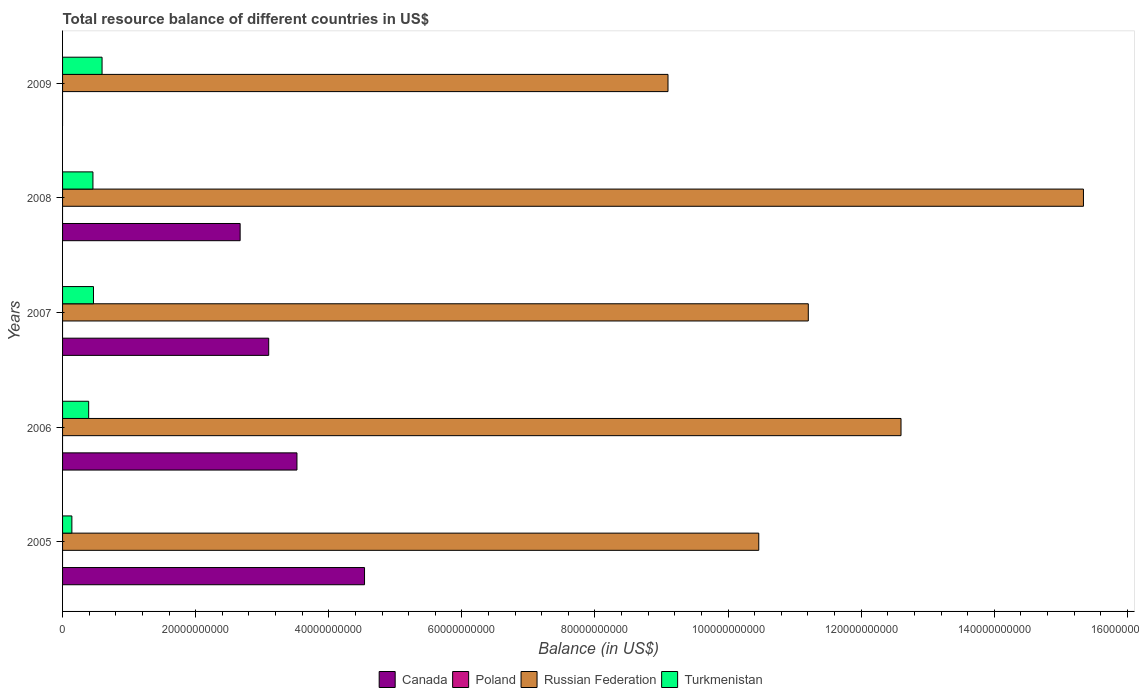How many groups of bars are there?
Offer a terse response. 5. How many bars are there on the 4th tick from the top?
Provide a short and direct response. 3. What is the label of the 3rd group of bars from the top?
Your answer should be very brief. 2007. What is the total resource balance in Turkmenistan in 2006?
Provide a short and direct response. 3.92e+09. Across all years, what is the maximum total resource balance in Russian Federation?
Keep it short and to the point. 1.53e+11. Across all years, what is the minimum total resource balance in Turkmenistan?
Provide a short and direct response. 1.40e+09. In which year was the total resource balance in Russian Federation maximum?
Your answer should be compact. 2008. What is the difference between the total resource balance in Turkmenistan in 2006 and that in 2007?
Your answer should be very brief. -7.24e+08. What is the difference between the total resource balance in Russian Federation in 2006 and the total resource balance in Canada in 2009?
Keep it short and to the point. 1.26e+11. What is the average total resource balance in Canada per year?
Your answer should be very brief. 2.77e+1. In the year 2006, what is the difference between the total resource balance in Turkmenistan and total resource balance in Canada?
Provide a short and direct response. -3.13e+1. In how many years, is the total resource balance in Turkmenistan greater than 40000000000 US$?
Make the answer very short. 0. What is the ratio of the total resource balance in Russian Federation in 2007 to that in 2009?
Offer a terse response. 1.23. Is the total resource balance in Russian Federation in 2005 less than that in 2006?
Ensure brevity in your answer.  Yes. Is the difference between the total resource balance in Turkmenistan in 2007 and 2008 greater than the difference between the total resource balance in Canada in 2007 and 2008?
Your answer should be very brief. No. What is the difference between the highest and the second highest total resource balance in Russian Federation?
Your answer should be compact. 2.74e+1. What is the difference between the highest and the lowest total resource balance in Canada?
Offer a very short reply. 4.54e+1. Is the sum of the total resource balance in Russian Federation in 2006 and 2008 greater than the maximum total resource balance in Turkmenistan across all years?
Keep it short and to the point. Yes. Is it the case that in every year, the sum of the total resource balance in Russian Federation and total resource balance in Poland is greater than the sum of total resource balance in Canada and total resource balance in Turkmenistan?
Your answer should be compact. Yes. How many bars are there?
Give a very brief answer. 14. Are all the bars in the graph horizontal?
Your answer should be very brief. Yes. What is the difference between two consecutive major ticks on the X-axis?
Provide a succinct answer. 2.00e+1. Does the graph contain any zero values?
Ensure brevity in your answer.  Yes. Does the graph contain grids?
Your answer should be compact. No. Where does the legend appear in the graph?
Keep it short and to the point. Bottom center. How are the legend labels stacked?
Keep it short and to the point. Horizontal. What is the title of the graph?
Your answer should be compact. Total resource balance of different countries in US$. Does "Isle of Man" appear as one of the legend labels in the graph?
Offer a terse response. No. What is the label or title of the X-axis?
Provide a succinct answer. Balance (in US$). What is the Balance (in US$) of Canada in 2005?
Offer a terse response. 4.54e+1. What is the Balance (in US$) in Poland in 2005?
Offer a terse response. 0. What is the Balance (in US$) of Russian Federation in 2005?
Provide a succinct answer. 1.05e+11. What is the Balance (in US$) in Turkmenistan in 2005?
Keep it short and to the point. 1.40e+09. What is the Balance (in US$) in Canada in 2006?
Offer a very short reply. 3.52e+1. What is the Balance (in US$) in Poland in 2006?
Offer a very short reply. 0. What is the Balance (in US$) in Russian Federation in 2006?
Provide a short and direct response. 1.26e+11. What is the Balance (in US$) in Turkmenistan in 2006?
Provide a short and direct response. 3.92e+09. What is the Balance (in US$) in Canada in 2007?
Your answer should be compact. 3.10e+1. What is the Balance (in US$) in Russian Federation in 2007?
Ensure brevity in your answer.  1.12e+11. What is the Balance (in US$) in Turkmenistan in 2007?
Provide a short and direct response. 4.65e+09. What is the Balance (in US$) of Canada in 2008?
Your answer should be very brief. 2.67e+1. What is the Balance (in US$) in Poland in 2008?
Ensure brevity in your answer.  0. What is the Balance (in US$) of Russian Federation in 2008?
Your answer should be very brief. 1.53e+11. What is the Balance (in US$) of Turkmenistan in 2008?
Offer a terse response. 4.56e+09. What is the Balance (in US$) in Poland in 2009?
Your answer should be very brief. 0. What is the Balance (in US$) of Russian Federation in 2009?
Your response must be concise. 9.10e+1. What is the Balance (in US$) of Turkmenistan in 2009?
Offer a terse response. 5.93e+09. Across all years, what is the maximum Balance (in US$) of Canada?
Ensure brevity in your answer.  4.54e+1. Across all years, what is the maximum Balance (in US$) of Russian Federation?
Ensure brevity in your answer.  1.53e+11. Across all years, what is the maximum Balance (in US$) of Turkmenistan?
Provide a short and direct response. 5.93e+09. Across all years, what is the minimum Balance (in US$) in Russian Federation?
Provide a short and direct response. 9.10e+1. Across all years, what is the minimum Balance (in US$) of Turkmenistan?
Provide a short and direct response. 1.40e+09. What is the total Balance (in US$) of Canada in the graph?
Provide a succinct answer. 1.38e+11. What is the total Balance (in US$) of Poland in the graph?
Your answer should be very brief. 0. What is the total Balance (in US$) of Russian Federation in the graph?
Your response must be concise. 5.87e+11. What is the total Balance (in US$) in Turkmenistan in the graph?
Give a very brief answer. 2.05e+1. What is the difference between the Balance (in US$) in Canada in 2005 and that in 2006?
Your answer should be very brief. 1.02e+1. What is the difference between the Balance (in US$) in Russian Federation in 2005 and that in 2006?
Offer a very short reply. -2.14e+1. What is the difference between the Balance (in US$) in Turkmenistan in 2005 and that in 2006?
Your answer should be very brief. -2.52e+09. What is the difference between the Balance (in US$) in Canada in 2005 and that in 2007?
Keep it short and to the point. 1.44e+1. What is the difference between the Balance (in US$) in Russian Federation in 2005 and that in 2007?
Provide a succinct answer. -7.44e+09. What is the difference between the Balance (in US$) in Turkmenistan in 2005 and that in 2007?
Your answer should be very brief. -3.25e+09. What is the difference between the Balance (in US$) in Canada in 2005 and that in 2008?
Ensure brevity in your answer.  1.87e+1. What is the difference between the Balance (in US$) of Russian Federation in 2005 and that in 2008?
Ensure brevity in your answer.  -4.88e+1. What is the difference between the Balance (in US$) in Turkmenistan in 2005 and that in 2008?
Keep it short and to the point. -3.17e+09. What is the difference between the Balance (in US$) of Russian Federation in 2005 and that in 2009?
Your answer should be very brief. 1.36e+1. What is the difference between the Balance (in US$) in Turkmenistan in 2005 and that in 2009?
Keep it short and to the point. -4.54e+09. What is the difference between the Balance (in US$) of Canada in 2006 and that in 2007?
Make the answer very short. 4.24e+09. What is the difference between the Balance (in US$) of Russian Federation in 2006 and that in 2007?
Provide a short and direct response. 1.39e+1. What is the difference between the Balance (in US$) in Turkmenistan in 2006 and that in 2007?
Keep it short and to the point. -7.24e+08. What is the difference between the Balance (in US$) of Canada in 2006 and that in 2008?
Your response must be concise. 8.54e+09. What is the difference between the Balance (in US$) of Russian Federation in 2006 and that in 2008?
Make the answer very short. -2.74e+1. What is the difference between the Balance (in US$) of Turkmenistan in 2006 and that in 2008?
Offer a very short reply. -6.41e+08. What is the difference between the Balance (in US$) in Russian Federation in 2006 and that in 2009?
Provide a succinct answer. 3.50e+1. What is the difference between the Balance (in US$) in Turkmenistan in 2006 and that in 2009?
Provide a succinct answer. -2.01e+09. What is the difference between the Balance (in US$) of Canada in 2007 and that in 2008?
Offer a terse response. 4.29e+09. What is the difference between the Balance (in US$) in Russian Federation in 2007 and that in 2008?
Give a very brief answer. -4.13e+1. What is the difference between the Balance (in US$) in Turkmenistan in 2007 and that in 2008?
Provide a succinct answer. 8.30e+07. What is the difference between the Balance (in US$) of Russian Federation in 2007 and that in 2009?
Make the answer very short. 2.11e+1. What is the difference between the Balance (in US$) of Turkmenistan in 2007 and that in 2009?
Give a very brief answer. -1.29e+09. What is the difference between the Balance (in US$) in Russian Federation in 2008 and that in 2009?
Your answer should be compact. 6.24e+1. What is the difference between the Balance (in US$) in Turkmenistan in 2008 and that in 2009?
Your response must be concise. -1.37e+09. What is the difference between the Balance (in US$) in Canada in 2005 and the Balance (in US$) in Russian Federation in 2006?
Ensure brevity in your answer.  -8.06e+1. What is the difference between the Balance (in US$) of Canada in 2005 and the Balance (in US$) of Turkmenistan in 2006?
Your answer should be very brief. 4.15e+1. What is the difference between the Balance (in US$) of Russian Federation in 2005 and the Balance (in US$) of Turkmenistan in 2006?
Offer a terse response. 1.01e+11. What is the difference between the Balance (in US$) in Canada in 2005 and the Balance (in US$) in Russian Federation in 2007?
Ensure brevity in your answer.  -6.67e+1. What is the difference between the Balance (in US$) of Canada in 2005 and the Balance (in US$) of Turkmenistan in 2007?
Your answer should be very brief. 4.07e+1. What is the difference between the Balance (in US$) of Russian Federation in 2005 and the Balance (in US$) of Turkmenistan in 2007?
Give a very brief answer. 1.00e+11. What is the difference between the Balance (in US$) in Canada in 2005 and the Balance (in US$) in Russian Federation in 2008?
Your answer should be very brief. -1.08e+11. What is the difference between the Balance (in US$) in Canada in 2005 and the Balance (in US$) in Turkmenistan in 2008?
Your answer should be very brief. 4.08e+1. What is the difference between the Balance (in US$) in Russian Federation in 2005 and the Balance (in US$) in Turkmenistan in 2008?
Offer a terse response. 1.00e+11. What is the difference between the Balance (in US$) of Canada in 2005 and the Balance (in US$) of Russian Federation in 2009?
Your response must be concise. -4.56e+1. What is the difference between the Balance (in US$) in Canada in 2005 and the Balance (in US$) in Turkmenistan in 2009?
Your answer should be compact. 3.94e+1. What is the difference between the Balance (in US$) in Russian Federation in 2005 and the Balance (in US$) in Turkmenistan in 2009?
Offer a very short reply. 9.87e+1. What is the difference between the Balance (in US$) of Canada in 2006 and the Balance (in US$) of Russian Federation in 2007?
Your answer should be very brief. -7.68e+1. What is the difference between the Balance (in US$) in Canada in 2006 and the Balance (in US$) in Turkmenistan in 2007?
Offer a very short reply. 3.06e+1. What is the difference between the Balance (in US$) in Russian Federation in 2006 and the Balance (in US$) in Turkmenistan in 2007?
Provide a succinct answer. 1.21e+11. What is the difference between the Balance (in US$) of Canada in 2006 and the Balance (in US$) of Russian Federation in 2008?
Ensure brevity in your answer.  -1.18e+11. What is the difference between the Balance (in US$) in Canada in 2006 and the Balance (in US$) in Turkmenistan in 2008?
Your answer should be very brief. 3.07e+1. What is the difference between the Balance (in US$) of Russian Federation in 2006 and the Balance (in US$) of Turkmenistan in 2008?
Ensure brevity in your answer.  1.21e+11. What is the difference between the Balance (in US$) of Canada in 2006 and the Balance (in US$) of Russian Federation in 2009?
Provide a succinct answer. -5.58e+1. What is the difference between the Balance (in US$) in Canada in 2006 and the Balance (in US$) in Turkmenistan in 2009?
Your response must be concise. 2.93e+1. What is the difference between the Balance (in US$) in Russian Federation in 2006 and the Balance (in US$) in Turkmenistan in 2009?
Your answer should be very brief. 1.20e+11. What is the difference between the Balance (in US$) of Canada in 2007 and the Balance (in US$) of Russian Federation in 2008?
Provide a short and direct response. -1.22e+11. What is the difference between the Balance (in US$) in Canada in 2007 and the Balance (in US$) in Turkmenistan in 2008?
Give a very brief answer. 2.64e+1. What is the difference between the Balance (in US$) of Russian Federation in 2007 and the Balance (in US$) of Turkmenistan in 2008?
Give a very brief answer. 1.07e+11. What is the difference between the Balance (in US$) of Canada in 2007 and the Balance (in US$) of Russian Federation in 2009?
Make the answer very short. -6.00e+1. What is the difference between the Balance (in US$) of Canada in 2007 and the Balance (in US$) of Turkmenistan in 2009?
Your answer should be very brief. 2.50e+1. What is the difference between the Balance (in US$) of Russian Federation in 2007 and the Balance (in US$) of Turkmenistan in 2009?
Offer a very short reply. 1.06e+11. What is the difference between the Balance (in US$) in Canada in 2008 and the Balance (in US$) in Russian Federation in 2009?
Your answer should be compact. -6.43e+1. What is the difference between the Balance (in US$) of Canada in 2008 and the Balance (in US$) of Turkmenistan in 2009?
Ensure brevity in your answer.  2.08e+1. What is the difference between the Balance (in US$) in Russian Federation in 2008 and the Balance (in US$) in Turkmenistan in 2009?
Give a very brief answer. 1.47e+11. What is the average Balance (in US$) of Canada per year?
Ensure brevity in your answer.  2.77e+1. What is the average Balance (in US$) in Poland per year?
Offer a very short reply. 0. What is the average Balance (in US$) of Russian Federation per year?
Your answer should be very brief. 1.17e+11. What is the average Balance (in US$) of Turkmenistan per year?
Keep it short and to the point. 4.09e+09. In the year 2005, what is the difference between the Balance (in US$) of Canada and Balance (in US$) of Russian Federation?
Offer a terse response. -5.92e+1. In the year 2005, what is the difference between the Balance (in US$) of Canada and Balance (in US$) of Turkmenistan?
Ensure brevity in your answer.  4.40e+1. In the year 2005, what is the difference between the Balance (in US$) in Russian Federation and Balance (in US$) in Turkmenistan?
Make the answer very short. 1.03e+11. In the year 2006, what is the difference between the Balance (in US$) in Canada and Balance (in US$) in Russian Federation?
Provide a succinct answer. -9.08e+1. In the year 2006, what is the difference between the Balance (in US$) of Canada and Balance (in US$) of Turkmenistan?
Your answer should be very brief. 3.13e+1. In the year 2006, what is the difference between the Balance (in US$) in Russian Federation and Balance (in US$) in Turkmenistan?
Make the answer very short. 1.22e+11. In the year 2007, what is the difference between the Balance (in US$) in Canada and Balance (in US$) in Russian Federation?
Provide a short and direct response. -8.11e+1. In the year 2007, what is the difference between the Balance (in US$) in Canada and Balance (in US$) in Turkmenistan?
Your response must be concise. 2.63e+1. In the year 2007, what is the difference between the Balance (in US$) in Russian Federation and Balance (in US$) in Turkmenistan?
Provide a short and direct response. 1.07e+11. In the year 2008, what is the difference between the Balance (in US$) of Canada and Balance (in US$) of Russian Federation?
Ensure brevity in your answer.  -1.27e+11. In the year 2008, what is the difference between the Balance (in US$) in Canada and Balance (in US$) in Turkmenistan?
Your response must be concise. 2.21e+1. In the year 2008, what is the difference between the Balance (in US$) in Russian Federation and Balance (in US$) in Turkmenistan?
Give a very brief answer. 1.49e+11. In the year 2009, what is the difference between the Balance (in US$) in Russian Federation and Balance (in US$) in Turkmenistan?
Provide a short and direct response. 8.50e+1. What is the ratio of the Balance (in US$) in Canada in 2005 to that in 2006?
Provide a short and direct response. 1.29. What is the ratio of the Balance (in US$) of Russian Federation in 2005 to that in 2006?
Keep it short and to the point. 0.83. What is the ratio of the Balance (in US$) of Turkmenistan in 2005 to that in 2006?
Make the answer very short. 0.36. What is the ratio of the Balance (in US$) of Canada in 2005 to that in 2007?
Keep it short and to the point. 1.46. What is the ratio of the Balance (in US$) in Russian Federation in 2005 to that in 2007?
Keep it short and to the point. 0.93. What is the ratio of the Balance (in US$) in Turkmenistan in 2005 to that in 2007?
Provide a succinct answer. 0.3. What is the ratio of the Balance (in US$) in Canada in 2005 to that in 2008?
Your answer should be very brief. 1.7. What is the ratio of the Balance (in US$) in Russian Federation in 2005 to that in 2008?
Provide a short and direct response. 0.68. What is the ratio of the Balance (in US$) in Turkmenistan in 2005 to that in 2008?
Make the answer very short. 0.31. What is the ratio of the Balance (in US$) of Russian Federation in 2005 to that in 2009?
Provide a succinct answer. 1.15. What is the ratio of the Balance (in US$) of Turkmenistan in 2005 to that in 2009?
Make the answer very short. 0.24. What is the ratio of the Balance (in US$) in Canada in 2006 to that in 2007?
Your answer should be very brief. 1.14. What is the ratio of the Balance (in US$) in Russian Federation in 2006 to that in 2007?
Offer a terse response. 1.12. What is the ratio of the Balance (in US$) in Turkmenistan in 2006 to that in 2007?
Make the answer very short. 0.84. What is the ratio of the Balance (in US$) in Canada in 2006 to that in 2008?
Offer a very short reply. 1.32. What is the ratio of the Balance (in US$) in Russian Federation in 2006 to that in 2008?
Give a very brief answer. 0.82. What is the ratio of the Balance (in US$) in Turkmenistan in 2006 to that in 2008?
Provide a succinct answer. 0.86. What is the ratio of the Balance (in US$) of Russian Federation in 2006 to that in 2009?
Offer a very short reply. 1.38. What is the ratio of the Balance (in US$) in Turkmenistan in 2006 to that in 2009?
Your response must be concise. 0.66. What is the ratio of the Balance (in US$) of Canada in 2007 to that in 2008?
Offer a terse response. 1.16. What is the ratio of the Balance (in US$) of Russian Federation in 2007 to that in 2008?
Keep it short and to the point. 0.73. What is the ratio of the Balance (in US$) in Turkmenistan in 2007 to that in 2008?
Provide a short and direct response. 1.02. What is the ratio of the Balance (in US$) of Russian Federation in 2007 to that in 2009?
Offer a terse response. 1.23. What is the ratio of the Balance (in US$) of Turkmenistan in 2007 to that in 2009?
Your response must be concise. 0.78. What is the ratio of the Balance (in US$) of Russian Federation in 2008 to that in 2009?
Offer a very short reply. 1.69. What is the ratio of the Balance (in US$) of Turkmenistan in 2008 to that in 2009?
Make the answer very short. 0.77. What is the difference between the highest and the second highest Balance (in US$) of Canada?
Provide a short and direct response. 1.02e+1. What is the difference between the highest and the second highest Balance (in US$) of Russian Federation?
Give a very brief answer. 2.74e+1. What is the difference between the highest and the second highest Balance (in US$) of Turkmenistan?
Provide a short and direct response. 1.29e+09. What is the difference between the highest and the lowest Balance (in US$) in Canada?
Offer a terse response. 4.54e+1. What is the difference between the highest and the lowest Balance (in US$) in Russian Federation?
Your answer should be very brief. 6.24e+1. What is the difference between the highest and the lowest Balance (in US$) in Turkmenistan?
Give a very brief answer. 4.54e+09. 